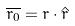<formula> <loc_0><loc_0><loc_500><loc_500>\overline { r _ { 0 } } = r \cdot \hat { r }</formula> 